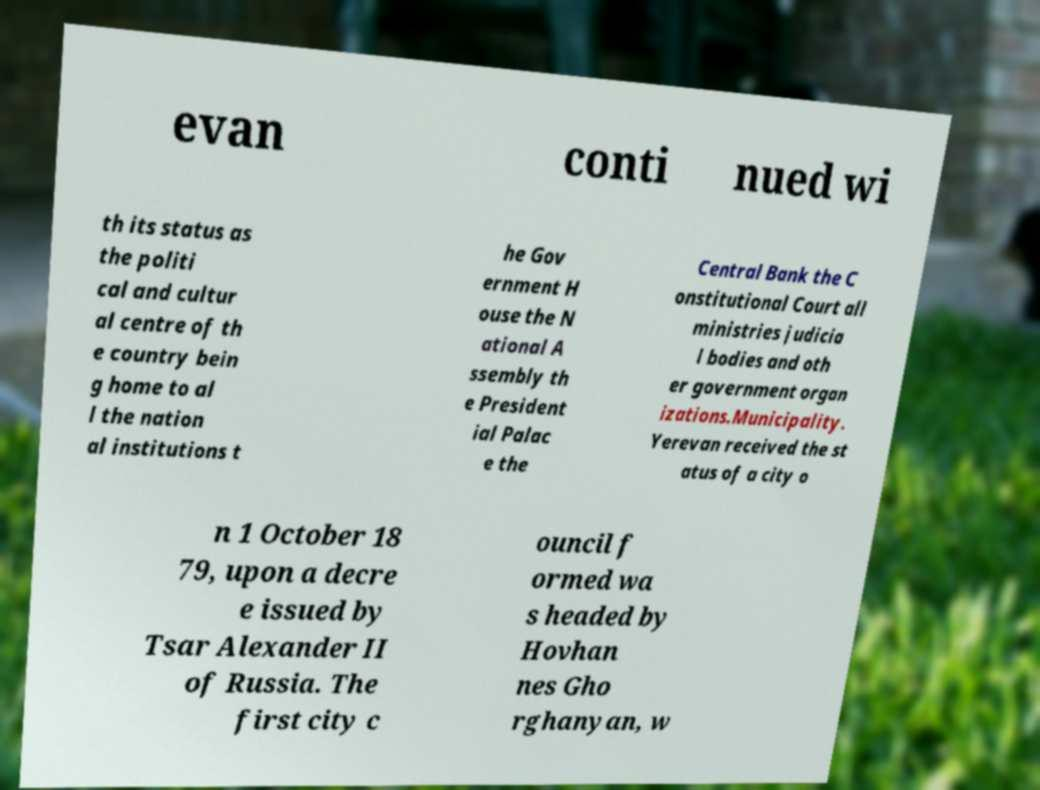Could you extract and type out the text from this image? evan conti nued wi th its status as the politi cal and cultur al centre of th e country bein g home to al l the nation al institutions t he Gov ernment H ouse the N ational A ssembly th e President ial Palac e the Central Bank the C onstitutional Court all ministries judicia l bodies and oth er government organ izations.Municipality. Yerevan received the st atus of a city o n 1 October 18 79, upon a decre e issued by Tsar Alexander II of Russia. The first city c ouncil f ormed wa s headed by Hovhan nes Gho rghanyan, w 